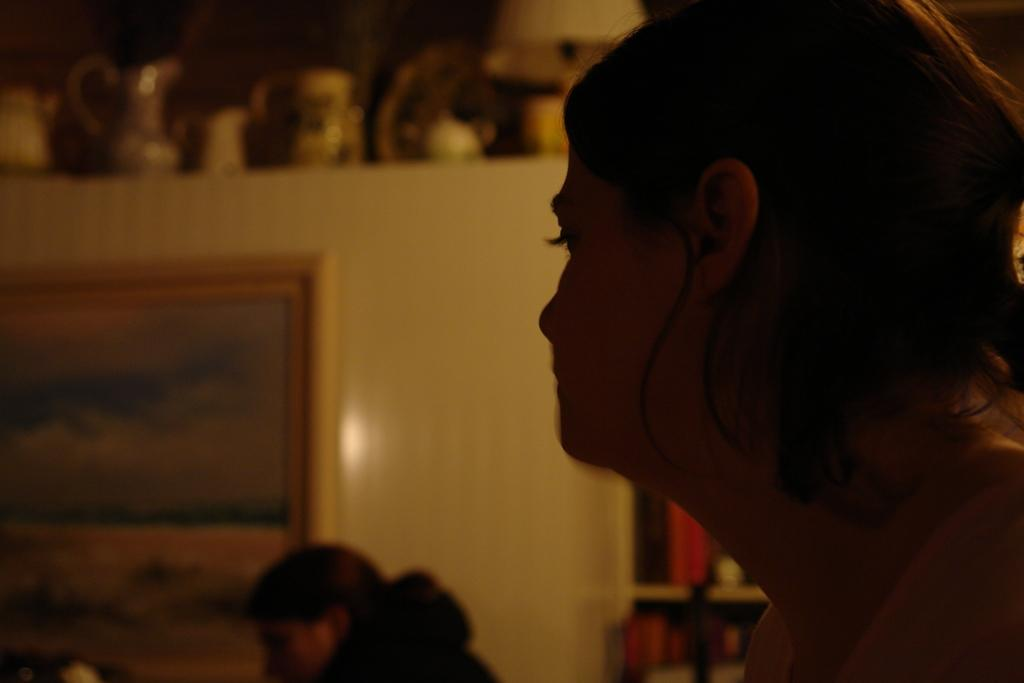Who or what is present in the image? There is a person in the image. What can be observed about the person's attire? The person is wearing clothes. What type of object is present in the image that might be used for displaying or framing? There is a frame in the image. What type of containers can be seen in the image? There are jars in the image. Where is the toothbrush located in the image? There is no toothbrush present in the image. What type of key is being used to open the jars in the image? There are no keys or jars being opened in the image. 